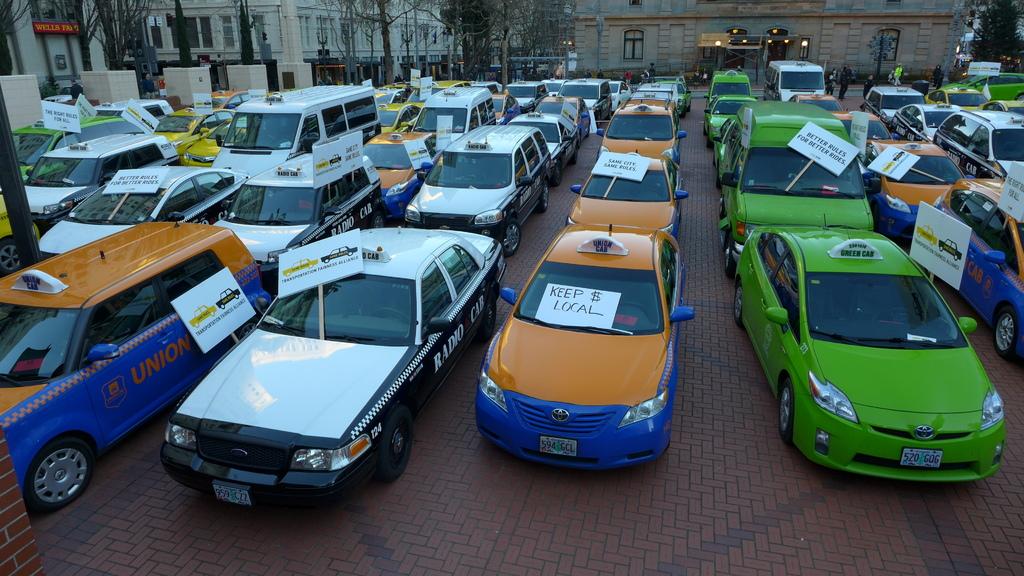What should you keep local?
Offer a terse response. Money. For better "what?" for better rides?
Your answer should be compact. Rules. 